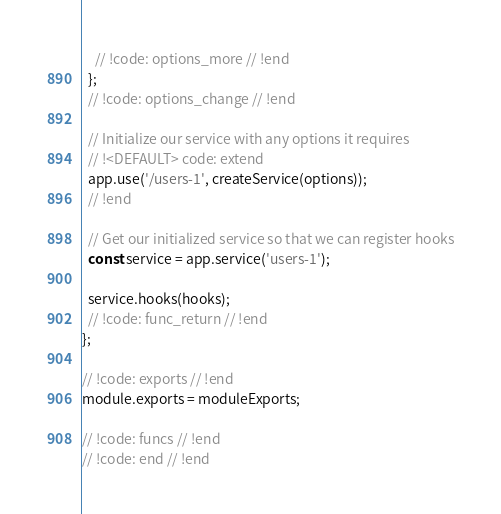Convert code to text. <code><loc_0><loc_0><loc_500><loc_500><_JavaScript_>    // !code: options_more // !end
  };
  // !code: options_change // !end

  // Initialize our service with any options it requires
  // !<DEFAULT> code: extend
  app.use('/users-1', createService(options));
  // !end

  // Get our initialized service so that we can register hooks
  const service = app.service('users-1');

  service.hooks(hooks);
  // !code: func_return // !end
};

// !code: exports // !end
module.exports = moduleExports;

// !code: funcs // !end
// !code: end // !end
</code> 